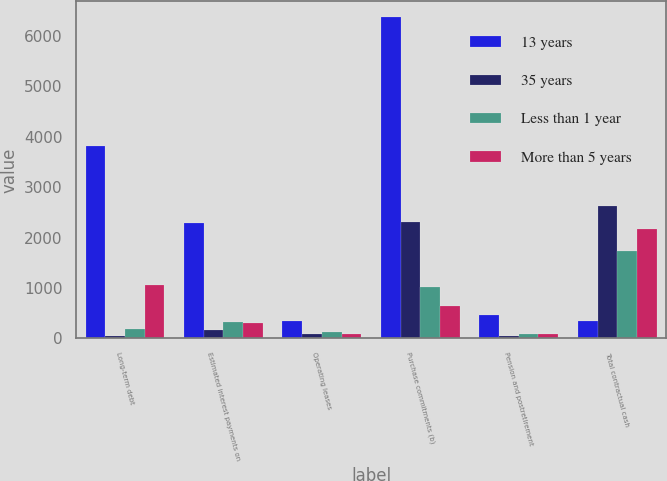<chart> <loc_0><loc_0><loc_500><loc_500><stacked_bar_chart><ecel><fcel>Long-term debt<fcel>Estimated interest payments on<fcel>Operating leases<fcel>Purchase commitments (b)<fcel>Pension and postretirement<fcel>Total contractual cash<nl><fcel>13 years<fcel>3818.1<fcel>2281<fcel>339.2<fcel>6367.7<fcel>463<fcel>339.2<nl><fcel>35 years<fcel>38.8<fcel>164.1<fcel>81.5<fcel>2300.3<fcel>44.3<fcel>2629<nl><fcel>Less than 1 year<fcel>188.8<fcel>316.1<fcel>115.6<fcel>1019.9<fcel>90.8<fcel>1731.2<nl><fcel>More than 5 years<fcel>1049.3<fcel>306.9<fcel>76.5<fcel>635.4<fcel>92.8<fcel>2160.9<nl></chart> 